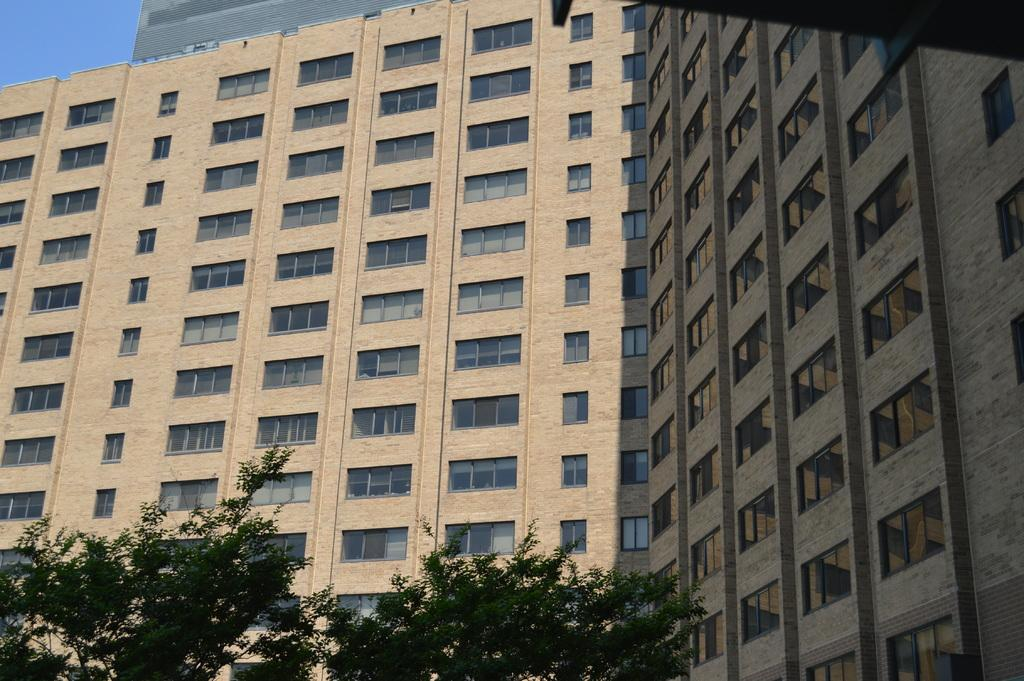What type of structure is visible in the image? There is a building in the image. What feature can be seen on the building? The building has windows. What type of vegetation is present at the bottom of the image? There are trees at the bottom of the image. What type of locket is hanging from the tree in the image? There is no locket present in the image; it only features a building and trees. 